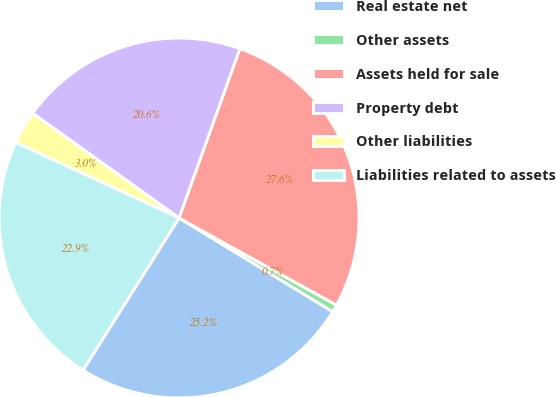Convert chart. <chart><loc_0><loc_0><loc_500><loc_500><pie_chart><fcel>Real estate net<fcel>Other assets<fcel>Assets held for sale<fcel>Property debt<fcel>Other liabilities<fcel>Liabilities related to assets<nl><fcel>25.24%<fcel>0.67%<fcel>27.56%<fcel>20.61%<fcel>2.99%<fcel>22.93%<nl></chart> 